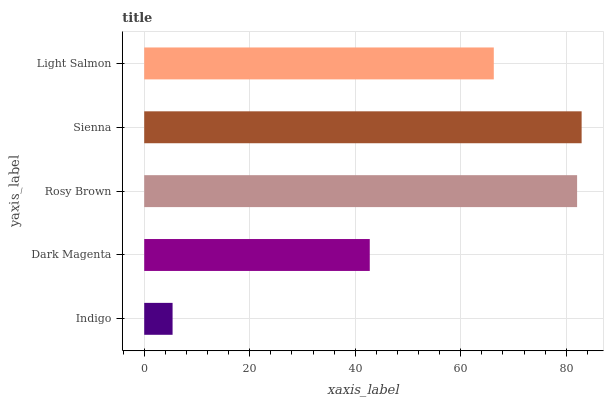Is Indigo the minimum?
Answer yes or no. Yes. Is Sienna the maximum?
Answer yes or no. Yes. Is Dark Magenta the minimum?
Answer yes or no. No. Is Dark Magenta the maximum?
Answer yes or no. No. Is Dark Magenta greater than Indigo?
Answer yes or no. Yes. Is Indigo less than Dark Magenta?
Answer yes or no. Yes. Is Indigo greater than Dark Magenta?
Answer yes or no. No. Is Dark Magenta less than Indigo?
Answer yes or no. No. Is Light Salmon the high median?
Answer yes or no. Yes. Is Light Salmon the low median?
Answer yes or no. Yes. Is Rosy Brown the high median?
Answer yes or no. No. Is Indigo the low median?
Answer yes or no. No. 